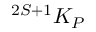Convert formula to latex. <formula><loc_0><loc_0><loc_500><loc_500>{ } ^ { 2 S + 1 } K _ { P }</formula> 